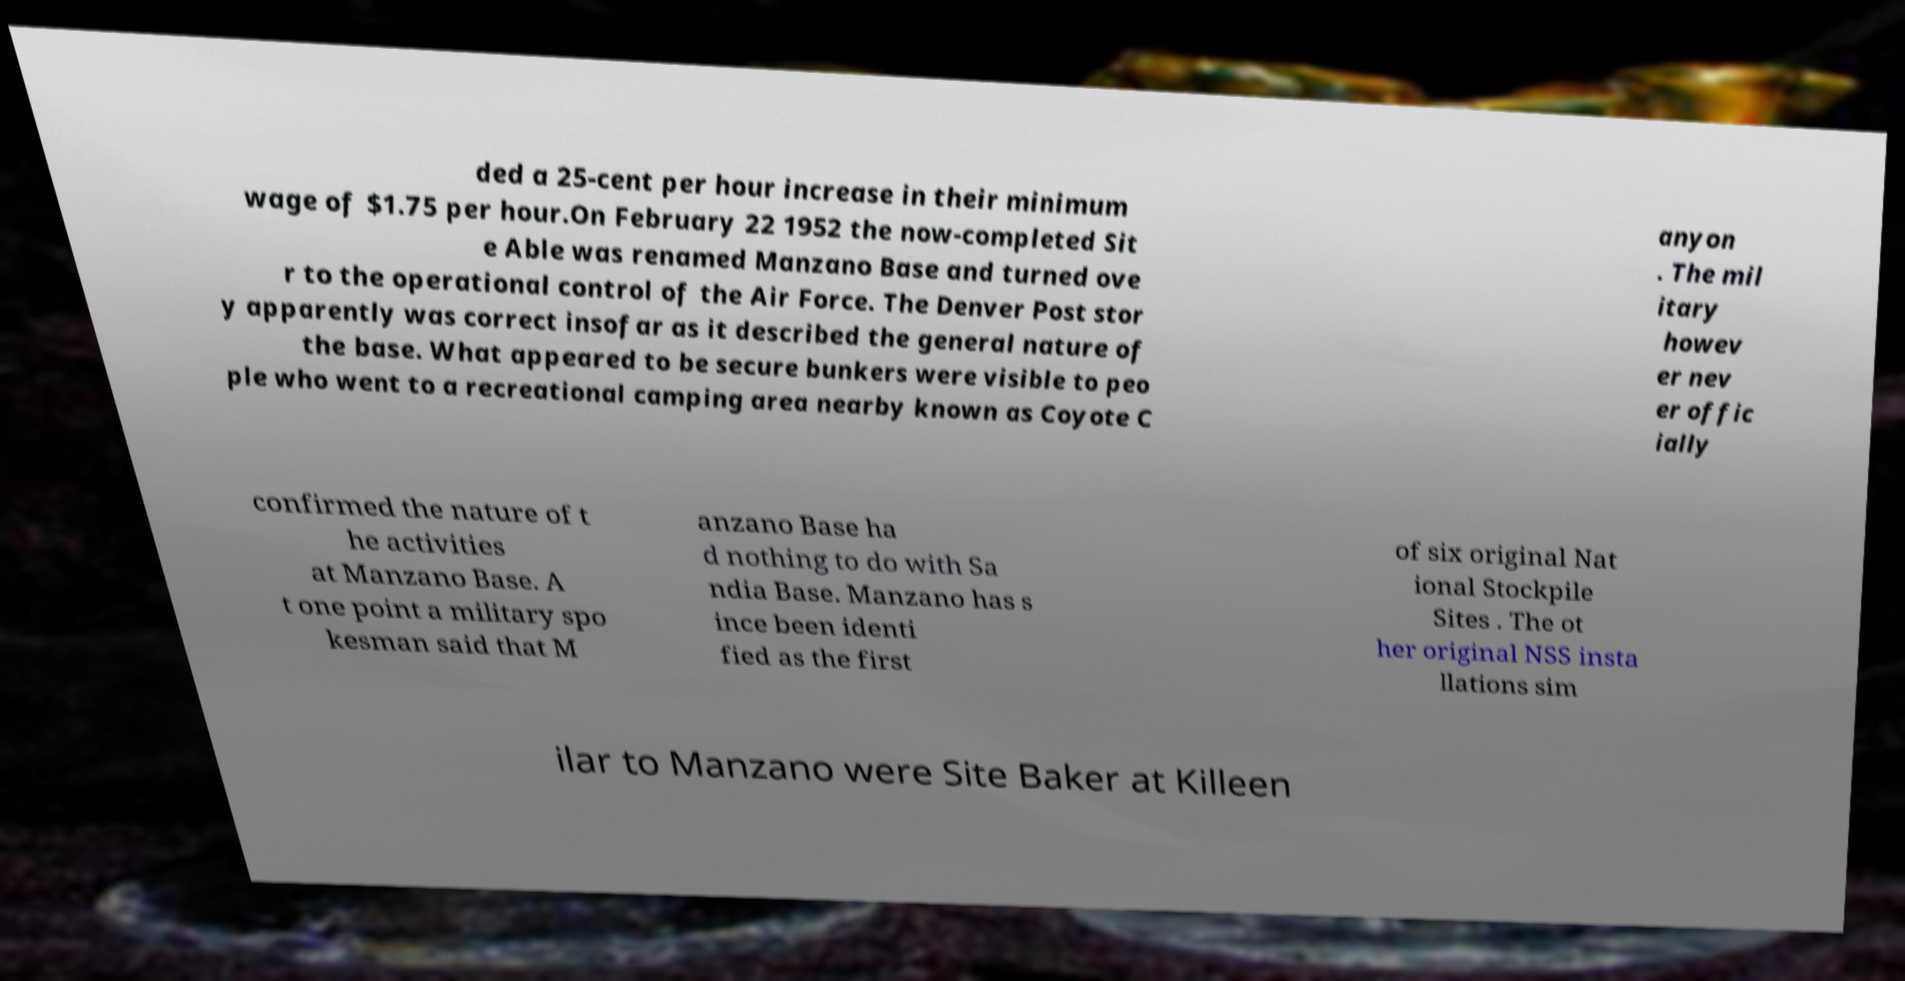Can you accurately transcribe the text from the provided image for me? ded a 25-cent per hour increase in their minimum wage of $1.75 per hour.On February 22 1952 the now-completed Sit e Able was renamed Manzano Base and turned ove r to the operational control of the Air Force. The Denver Post stor y apparently was correct insofar as it described the general nature of the base. What appeared to be secure bunkers were visible to peo ple who went to a recreational camping area nearby known as Coyote C anyon . The mil itary howev er nev er offic ially confirmed the nature of t he activities at Manzano Base. A t one point a military spo kesman said that M anzano Base ha d nothing to do with Sa ndia Base. Manzano has s ince been identi fied as the first of six original Nat ional Stockpile Sites . The ot her original NSS insta llations sim ilar to Manzano were Site Baker at Killeen 